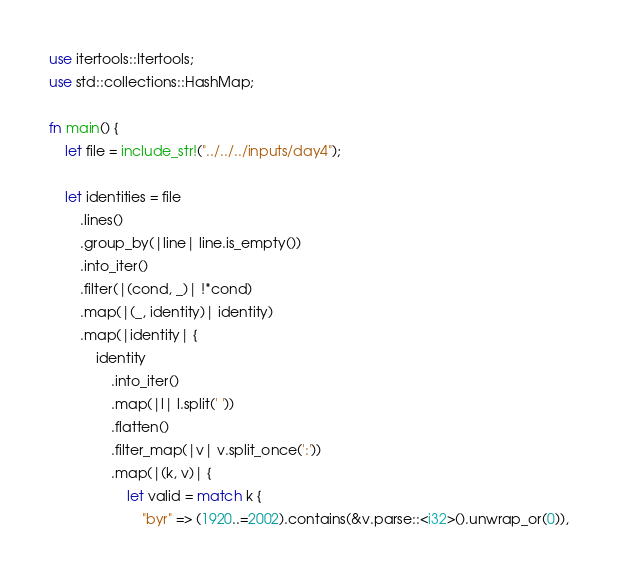Convert code to text. <code><loc_0><loc_0><loc_500><loc_500><_Rust_>use itertools::Itertools;
use std::collections::HashMap;

fn main() {
    let file = include_str!("../../../inputs/day4");

    let identities = file
        .lines()
        .group_by(|line| line.is_empty())
        .into_iter()
        .filter(|(cond, _)| !*cond)
        .map(|(_, identity)| identity)
        .map(|identity| {
            identity
                .into_iter()
                .map(|l| l.split(' '))
                .flatten()
                .filter_map(|v| v.split_once(':'))
                .map(|(k, v)| {
                    let valid = match k {
                        "byr" => (1920..=2002).contains(&v.parse::<i32>().unwrap_or(0)),</code> 